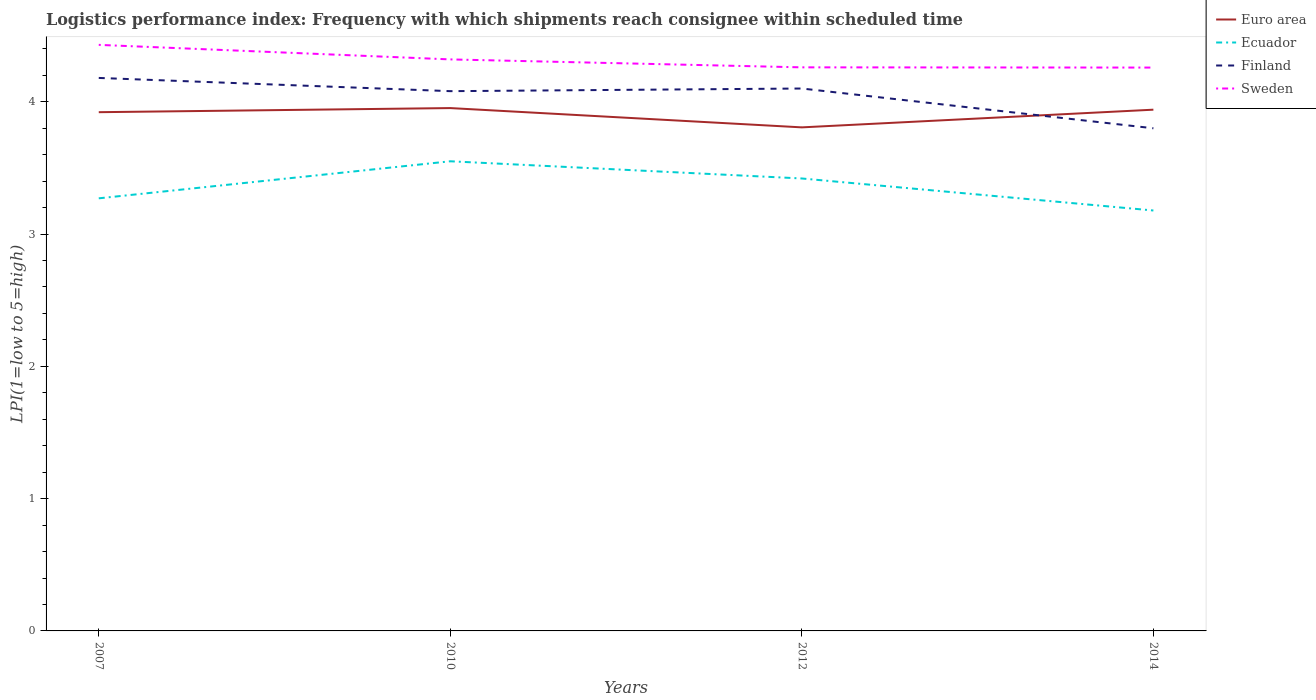Does the line corresponding to Ecuador intersect with the line corresponding to Finland?
Provide a short and direct response. No. Across all years, what is the maximum logistics performance index in Ecuador?
Give a very brief answer. 3.18. What is the total logistics performance index in Finland in the graph?
Offer a terse response. 0.28. What is the difference between the highest and the second highest logistics performance index in Finland?
Your answer should be very brief. 0.38. Is the logistics performance index in Sweden strictly greater than the logistics performance index in Finland over the years?
Give a very brief answer. No. Are the values on the major ticks of Y-axis written in scientific E-notation?
Offer a terse response. No. Does the graph contain any zero values?
Your answer should be very brief. No. Where does the legend appear in the graph?
Make the answer very short. Top right. How many legend labels are there?
Your answer should be compact. 4. How are the legend labels stacked?
Provide a succinct answer. Vertical. What is the title of the graph?
Keep it short and to the point. Logistics performance index: Frequency with which shipments reach consignee within scheduled time. Does "Comoros" appear as one of the legend labels in the graph?
Give a very brief answer. No. What is the label or title of the Y-axis?
Keep it short and to the point. LPI(1=low to 5=high). What is the LPI(1=low to 5=high) of Euro area in 2007?
Your response must be concise. 3.92. What is the LPI(1=low to 5=high) in Ecuador in 2007?
Keep it short and to the point. 3.27. What is the LPI(1=low to 5=high) in Finland in 2007?
Your response must be concise. 4.18. What is the LPI(1=low to 5=high) in Sweden in 2007?
Provide a short and direct response. 4.43. What is the LPI(1=low to 5=high) of Euro area in 2010?
Offer a terse response. 3.95. What is the LPI(1=low to 5=high) of Ecuador in 2010?
Provide a short and direct response. 3.55. What is the LPI(1=low to 5=high) in Finland in 2010?
Give a very brief answer. 4.08. What is the LPI(1=low to 5=high) in Sweden in 2010?
Give a very brief answer. 4.32. What is the LPI(1=low to 5=high) of Euro area in 2012?
Provide a succinct answer. 3.81. What is the LPI(1=low to 5=high) of Ecuador in 2012?
Your answer should be very brief. 3.42. What is the LPI(1=low to 5=high) of Sweden in 2012?
Your answer should be very brief. 4.26. What is the LPI(1=low to 5=high) of Euro area in 2014?
Your answer should be very brief. 3.94. What is the LPI(1=low to 5=high) in Ecuador in 2014?
Offer a terse response. 3.18. What is the LPI(1=low to 5=high) of Finland in 2014?
Make the answer very short. 3.8. What is the LPI(1=low to 5=high) in Sweden in 2014?
Make the answer very short. 4.26. Across all years, what is the maximum LPI(1=low to 5=high) of Euro area?
Provide a short and direct response. 3.95. Across all years, what is the maximum LPI(1=low to 5=high) of Ecuador?
Make the answer very short. 3.55. Across all years, what is the maximum LPI(1=low to 5=high) of Finland?
Your answer should be very brief. 4.18. Across all years, what is the maximum LPI(1=low to 5=high) of Sweden?
Give a very brief answer. 4.43. Across all years, what is the minimum LPI(1=low to 5=high) of Euro area?
Your answer should be compact. 3.81. Across all years, what is the minimum LPI(1=low to 5=high) in Ecuador?
Provide a succinct answer. 3.18. Across all years, what is the minimum LPI(1=low to 5=high) of Finland?
Keep it short and to the point. 3.8. Across all years, what is the minimum LPI(1=low to 5=high) in Sweden?
Your response must be concise. 4.26. What is the total LPI(1=low to 5=high) of Euro area in the graph?
Your response must be concise. 15.62. What is the total LPI(1=low to 5=high) in Ecuador in the graph?
Keep it short and to the point. 13.42. What is the total LPI(1=low to 5=high) in Finland in the graph?
Make the answer very short. 16.16. What is the total LPI(1=low to 5=high) of Sweden in the graph?
Provide a succinct answer. 17.27. What is the difference between the LPI(1=low to 5=high) of Euro area in 2007 and that in 2010?
Provide a succinct answer. -0.03. What is the difference between the LPI(1=low to 5=high) in Ecuador in 2007 and that in 2010?
Your answer should be compact. -0.28. What is the difference between the LPI(1=low to 5=high) in Sweden in 2007 and that in 2010?
Keep it short and to the point. 0.11. What is the difference between the LPI(1=low to 5=high) of Euro area in 2007 and that in 2012?
Keep it short and to the point. 0.11. What is the difference between the LPI(1=low to 5=high) of Ecuador in 2007 and that in 2012?
Your answer should be compact. -0.15. What is the difference between the LPI(1=low to 5=high) in Sweden in 2007 and that in 2012?
Give a very brief answer. 0.17. What is the difference between the LPI(1=low to 5=high) of Euro area in 2007 and that in 2014?
Provide a short and direct response. -0.02. What is the difference between the LPI(1=low to 5=high) in Ecuador in 2007 and that in 2014?
Give a very brief answer. 0.09. What is the difference between the LPI(1=low to 5=high) in Finland in 2007 and that in 2014?
Make the answer very short. 0.38. What is the difference between the LPI(1=low to 5=high) of Sweden in 2007 and that in 2014?
Provide a succinct answer. 0.17. What is the difference between the LPI(1=low to 5=high) in Euro area in 2010 and that in 2012?
Keep it short and to the point. 0.15. What is the difference between the LPI(1=low to 5=high) in Ecuador in 2010 and that in 2012?
Your response must be concise. 0.13. What is the difference between the LPI(1=low to 5=high) in Finland in 2010 and that in 2012?
Provide a succinct answer. -0.02. What is the difference between the LPI(1=low to 5=high) of Euro area in 2010 and that in 2014?
Keep it short and to the point. 0.01. What is the difference between the LPI(1=low to 5=high) of Ecuador in 2010 and that in 2014?
Offer a very short reply. 0.37. What is the difference between the LPI(1=low to 5=high) of Finland in 2010 and that in 2014?
Provide a short and direct response. 0.28. What is the difference between the LPI(1=low to 5=high) in Sweden in 2010 and that in 2014?
Offer a very short reply. 0.06. What is the difference between the LPI(1=low to 5=high) in Euro area in 2012 and that in 2014?
Make the answer very short. -0.13. What is the difference between the LPI(1=low to 5=high) in Ecuador in 2012 and that in 2014?
Offer a very short reply. 0.24. What is the difference between the LPI(1=low to 5=high) of Finland in 2012 and that in 2014?
Your answer should be very brief. 0.3. What is the difference between the LPI(1=low to 5=high) in Sweden in 2012 and that in 2014?
Offer a terse response. 0. What is the difference between the LPI(1=low to 5=high) of Euro area in 2007 and the LPI(1=low to 5=high) of Ecuador in 2010?
Provide a short and direct response. 0.37. What is the difference between the LPI(1=low to 5=high) in Euro area in 2007 and the LPI(1=low to 5=high) in Finland in 2010?
Provide a succinct answer. -0.16. What is the difference between the LPI(1=low to 5=high) of Euro area in 2007 and the LPI(1=low to 5=high) of Sweden in 2010?
Make the answer very short. -0.4. What is the difference between the LPI(1=low to 5=high) in Ecuador in 2007 and the LPI(1=low to 5=high) in Finland in 2010?
Offer a terse response. -0.81. What is the difference between the LPI(1=low to 5=high) in Ecuador in 2007 and the LPI(1=low to 5=high) in Sweden in 2010?
Offer a terse response. -1.05. What is the difference between the LPI(1=low to 5=high) in Finland in 2007 and the LPI(1=low to 5=high) in Sweden in 2010?
Keep it short and to the point. -0.14. What is the difference between the LPI(1=low to 5=high) of Euro area in 2007 and the LPI(1=low to 5=high) of Ecuador in 2012?
Your response must be concise. 0.5. What is the difference between the LPI(1=low to 5=high) in Euro area in 2007 and the LPI(1=low to 5=high) in Finland in 2012?
Make the answer very short. -0.18. What is the difference between the LPI(1=low to 5=high) of Euro area in 2007 and the LPI(1=low to 5=high) of Sweden in 2012?
Provide a short and direct response. -0.34. What is the difference between the LPI(1=low to 5=high) of Ecuador in 2007 and the LPI(1=low to 5=high) of Finland in 2012?
Your answer should be compact. -0.83. What is the difference between the LPI(1=low to 5=high) in Ecuador in 2007 and the LPI(1=low to 5=high) in Sweden in 2012?
Keep it short and to the point. -0.99. What is the difference between the LPI(1=low to 5=high) of Finland in 2007 and the LPI(1=low to 5=high) of Sweden in 2012?
Your answer should be very brief. -0.08. What is the difference between the LPI(1=low to 5=high) of Euro area in 2007 and the LPI(1=low to 5=high) of Ecuador in 2014?
Ensure brevity in your answer.  0.74. What is the difference between the LPI(1=low to 5=high) of Euro area in 2007 and the LPI(1=low to 5=high) of Finland in 2014?
Your answer should be compact. 0.12. What is the difference between the LPI(1=low to 5=high) in Euro area in 2007 and the LPI(1=low to 5=high) in Sweden in 2014?
Keep it short and to the point. -0.34. What is the difference between the LPI(1=low to 5=high) in Ecuador in 2007 and the LPI(1=low to 5=high) in Finland in 2014?
Your response must be concise. -0.53. What is the difference between the LPI(1=low to 5=high) of Ecuador in 2007 and the LPI(1=low to 5=high) of Sweden in 2014?
Provide a succinct answer. -0.99. What is the difference between the LPI(1=low to 5=high) in Finland in 2007 and the LPI(1=low to 5=high) in Sweden in 2014?
Offer a very short reply. -0.08. What is the difference between the LPI(1=low to 5=high) in Euro area in 2010 and the LPI(1=low to 5=high) in Ecuador in 2012?
Keep it short and to the point. 0.53. What is the difference between the LPI(1=low to 5=high) in Euro area in 2010 and the LPI(1=low to 5=high) in Finland in 2012?
Offer a very short reply. -0.15. What is the difference between the LPI(1=low to 5=high) of Euro area in 2010 and the LPI(1=low to 5=high) of Sweden in 2012?
Provide a short and direct response. -0.31. What is the difference between the LPI(1=low to 5=high) of Ecuador in 2010 and the LPI(1=low to 5=high) of Finland in 2012?
Your answer should be compact. -0.55. What is the difference between the LPI(1=low to 5=high) of Ecuador in 2010 and the LPI(1=low to 5=high) of Sweden in 2012?
Your answer should be compact. -0.71. What is the difference between the LPI(1=low to 5=high) of Finland in 2010 and the LPI(1=low to 5=high) of Sweden in 2012?
Provide a succinct answer. -0.18. What is the difference between the LPI(1=low to 5=high) of Euro area in 2010 and the LPI(1=low to 5=high) of Ecuador in 2014?
Your answer should be very brief. 0.77. What is the difference between the LPI(1=low to 5=high) in Euro area in 2010 and the LPI(1=low to 5=high) in Finland in 2014?
Make the answer very short. 0.15. What is the difference between the LPI(1=low to 5=high) of Euro area in 2010 and the LPI(1=low to 5=high) of Sweden in 2014?
Your answer should be compact. -0.31. What is the difference between the LPI(1=low to 5=high) in Ecuador in 2010 and the LPI(1=low to 5=high) in Finland in 2014?
Make the answer very short. -0.25. What is the difference between the LPI(1=low to 5=high) in Ecuador in 2010 and the LPI(1=low to 5=high) in Sweden in 2014?
Your response must be concise. -0.71. What is the difference between the LPI(1=low to 5=high) of Finland in 2010 and the LPI(1=low to 5=high) of Sweden in 2014?
Your answer should be compact. -0.18. What is the difference between the LPI(1=low to 5=high) in Euro area in 2012 and the LPI(1=low to 5=high) in Ecuador in 2014?
Keep it short and to the point. 0.63. What is the difference between the LPI(1=low to 5=high) of Euro area in 2012 and the LPI(1=low to 5=high) of Finland in 2014?
Your answer should be compact. 0.01. What is the difference between the LPI(1=low to 5=high) of Euro area in 2012 and the LPI(1=low to 5=high) of Sweden in 2014?
Offer a terse response. -0.45. What is the difference between the LPI(1=low to 5=high) in Ecuador in 2012 and the LPI(1=low to 5=high) in Finland in 2014?
Your response must be concise. -0.38. What is the difference between the LPI(1=low to 5=high) of Ecuador in 2012 and the LPI(1=low to 5=high) of Sweden in 2014?
Your answer should be compact. -0.84. What is the difference between the LPI(1=low to 5=high) in Finland in 2012 and the LPI(1=low to 5=high) in Sweden in 2014?
Offer a terse response. -0.16. What is the average LPI(1=low to 5=high) in Euro area per year?
Offer a very short reply. 3.9. What is the average LPI(1=low to 5=high) of Ecuador per year?
Provide a short and direct response. 3.35. What is the average LPI(1=low to 5=high) of Finland per year?
Provide a succinct answer. 4.04. What is the average LPI(1=low to 5=high) of Sweden per year?
Provide a short and direct response. 4.32. In the year 2007, what is the difference between the LPI(1=low to 5=high) in Euro area and LPI(1=low to 5=high) in Ecuador?
Your response must be concise. 0.65. In the year 2007, what is the difference between the LPI(1=low to 5=high) in Euro area and LPI(1=low to 5=high) in Finland?
Keep it short and to the point. -0.26. In the year 2007, what is the difference between the LPI(1=low to 5=high) in Euro area and LPI(1=low to 5=high) in Sweden?
Your response must be concise. -0.51. In the year 2007, what is the difference between the LPI(1=low to 5=high) in Ecuador and LPI(1=low to 5=high) in Finland?
Ensure brevity in your answer.  -0.91. In the year 2007, what is the difference between the LPI(1=low to 5=high) in Ecuador and LPI(1=low to 5=high) in Sweden?
Your response must be concise. -1.16. In the year 2007, what is the difference between the LPI(1=low to 5=high) of Finland and LPI(1=low to 5=high) of Sweden?
Ensure brevity in your answer.  -0.25. In the year 2010, what is the difference between the LPI(1=low to 5=high) in Euro area and LPI(1=low to 5=high) in Ecuador?
Provide a short and direct response. 0.4. In the year 2010, what is the difference between the LPI(1=low to 5=high) in Euro area and LPI(1=low to 5=high) in Finland?
Make the answer very short. -0.13. In the year 2010, what is the difference between the LPI(1=low to 5=high) in Euro area and LPI(1=low to 5=high) in Sweden?
Give a very brief answer. -0.37. In the year 2010, what is the difference between the LPI(1=low to 5=high) in Ecuador and LPI(1=low to 5=high) in Finland?
Your response must be concise. -0.53. In the year 2010, what is the difference between the LPI(1=low to 5=high) of Ecuador and LPI(1=low to 5=high) of Sweden?
Ensure brevity in your answer.  -0.77. In the year 2010, what is the difference between the LPI(1=low to 5=high) of Finland and LPI(1=low to 5=high) of Sweden?
Provide a short and direct response. -0.24. In the year 2012, what is the difference between the LPI(1=low to 5=high) in Euro area and LPI(1=low to 5=high) in Ecuador?
Give a very brief answer. 0.39. In the year 2012, what is the difference between the LPI(1=low to 5=high) in Euro area and LPI(1=low to 5=high) in Finland?
Provide a short and direct response. -0.29. In the year 2012, what is the difference between the LPI(1=low to 5=high) of Euro area and LPI(1=low to 5=high) of Sweden?
Your answer should be compact. -0.45. In the year 2012, what is the difference between the LPI(1=low to 5=high) of Ecuador and LPI(1=low to 5=high) of Finland?
Offer a terse response. -0.68. In the year 2012, what is the difference between the LPI(1=low to 5=high) of Ecuador and LPI(1=low to 5=high) of Sweden?
Provide a short and direct response. -0.84. In the year 2012, what is the difference between the LPI(1=low to 5=high) in Finland and LPI(1=low to 5=high) in Sweden?
Your answer should be very brief. -0.16. In the year 2014, what is the difference between the LPI(1=low to 5=high) in Euro area and LPI(1=low to 5=high) in Ecuador?
Provide a succinct answer. 0.76. In the year 2014, what is the difference between the LPI(1=low to 5=high) of Euro area and LPI(1=low to 5=high) of Finland?
Your response must be concise. 0.14. In the year 2014, what is the difference between the LPI(1=low to 5=high) in Euro area and LPI(1=low to 5=high) in Sweden?
Provide a succinct answer. -0.32. In the year 2014, what is the difference between the LPI(1=low to 5=high) in Ecuador and LPI(1=low to 5=high) in Finland?
Offer a very short reply. -0.62. In the year 2014, what is the difference between the LPI(1=low to 5=high) in Ecuador and LPI(1=low to 5=high) in Sweden?
Your answer should be compact. -1.08. In the year 2014, what is the difference between the LPI(1=low to 5=high) in Finland and LPI(1=low to 5=high) in Sweden?
Provide a short and direct response. -0.46. What is the ratio of the LPI(1=low to 5=high) of Ecuador in 2007 to that in 2010?
Your answer should be compact. 0.92. What is the ratio of the LPI(1=low to 5=high) in Finland in 2007 to that in 2010?
Make the answer very short. 1.02. What is the ratio of the LPI(1=low to 5=high) in Sweden in 2007 to that in 2010?
Ensure brevity in your answer.  1.03. What is the ratio of the LPI(1=low to 5=high) in Euro area in 2007 to that in 2012?
Ensure brevity in your answer.  1.03. What is the ratio of the LPI(1=low to 5=high) in Ecuador in 2007 to that in 2012?
Ensure brevity in your answer.  0.96. What is the ratio of the LPI(1=low to 5=high) of Finland in 2007 to that in 2012?
Your answer should be compact. 1.02. What is the ratio of the LPI(1=low to 5=high) of Sweden in 2007 to that in 2012?
Keep it short and to the point. 1.04. What is the ratio of the LPI(1=low to 5=high) in Ecuador in 2007 to that in 2014?
Give a very brief answer. 1.03. What is the ratio of the LPI(1=low to 5=high) in Finland in 2007 to that in 2014?
Make the answer very short. 1.1. What is the ratio of the LPI(1=low to 5=high) in Sweden in 2007 to that in 2014?
Make the answer very short. 1.04. What is the ratio of the LPI(1=low to 5=high) in Euro area in 2010 to that in 2012?
Provide a short and direct response. 1.04. What is the ratio of the LPI(1=low to 5=high) in Ecuador in 2010 to that in 2012?
Provide a succinct answer. 1.04. What is the ratio of the LPI(1=low to 5=high) of Finland in 2010 to that in 2012?
Give a very brief answer. 1. What is the ratio of the LPI(1=low to 5=high) in Sweden in 2010 to that in 2012?
Your response must be concise. 1.01. What is the ratio of the LPI(1=low to 5=high) of Ecuador in 2010 to that in 2014?
Offer a very short reply. 1.12. What is the ratio of the LPI(1=low to 5=high) in Finland in 2010 to that in 2014?
Keep it short and to the point. 1.07. What is the ratio of the LPI(1=low to 5=high) of Sweden in 2010 to that in 2014?
Your answer should be compact. 1.01. What is the ratio of the LPI(1=low to 5=high) of Euro area in 2012 to that in 2014?
Make the answer very short. 0.97. What is the ratio of the LPI(1=low to 5=high) in Ecuador in 2012 to that in 2014?
Offer a terse response. 1.08. What is the ratio of the LPI(1=low to 5=high) of Finland in 2012 to that in 2014?
Give a very brief answer. 1.08. What is the ratio of the LPI(1=low to 5=high) in Sweden in 2012 to that in 2014?
Your response must be concise. 1. What is the difference between the highest and the second highest LPI(1=low to 5=high) of Euro area?
Offer a very short reply. 0.01. What is the difference between the highest and the second highest LPI(1=low to 5=high) of Ecuador?
Provide a short and direct response. 0.13. What is the difference between the highest and the second highest LPI(1=low to 5=high) in Sweden?
Offer a terse response. 0.11. What is the difference between the highest and the lowest LPI(1=low to 5=high) in Euro area?
Your answer should be compact. 0.15. What is the difference between the highest and the lowest LPI(1=low to 5=high) of Ecuador?
Provide a succinct answer. 0.37. What is the difference between the highest and the lowest LPI(1=low to 5=high) in Finland?
Your response must be concise. 0.38. What is the difference between the highest and the lowest LPI(1=low to 5=high) of Sweden?
Keep it short and to the point. 0.17. 